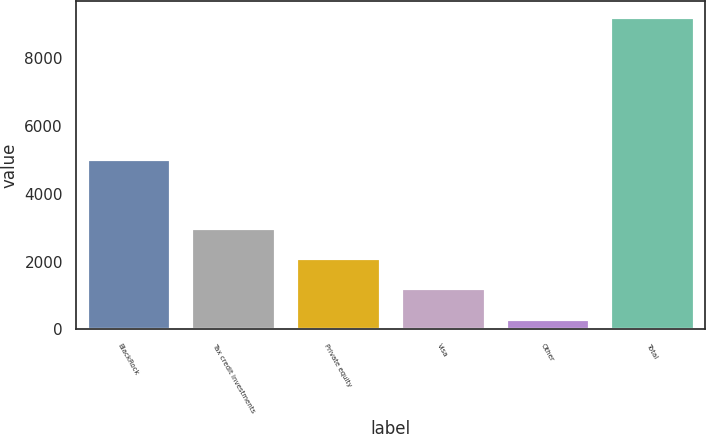Convert chart. <chart><loc_0><loc_0><loc_500><loc_500><bar_chart><fcel>BlackRock<fcel>Tax credit investments<fcel>Private equity<fcel>Visa<fcel>Other<fcel>Total<nl><fcel>5017<fcel>2988.6<fcel>2098.4<fcel>1208.2<fcel>318<fcel>9220<nl></chart> 